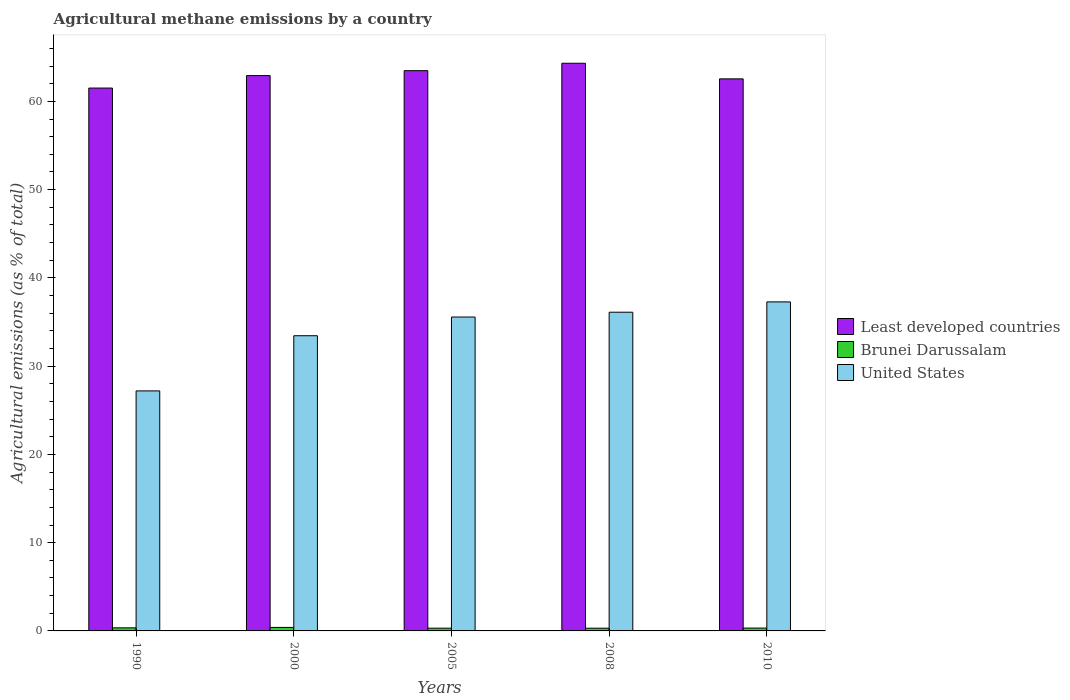How many different coloured bars are there?
Your answer should be compact. 3. Are the number of bars per tick equal to the number of legend labels?
Provide a short and direct response. Yes. How many bars are there on the 4th tick from the left?
Offer a terse response. 3. How many bars are there on the 1st tick from the right?
Offer a terse response. 3. What is the label of the 2nd group of bars from the left?
Give a very brief answer. 2000. What is the amount of agricultural methane emitted in Brunei Darussalam in 2005?
Your answer should be very brief. 0.31. Across all years, what is the maximum amount of agricultural methane emitted in Brunei Darussalam?
Provide a short and direct response. 0.4. Across all years, what is the minimum amount of agricultural methane emitted in Least developed countries?
Your answer should be very brief. 61.51. In which year was the amount of agricultural methane emitted in United States maximum?
Your answer should be very brief. 2010. In which year was the amount of agricultural methane emitted in Least developed countries minimum?
Your response must be concise. 1990. What is the total amount of agricultural methane emitted in Brunei Darussalam in the graph?
Offer a very short reply. 1.69. What is the difference between the amount of agricultural methane emitted in Brunei Darussalam in 2008 and that in 2010?
Give a very brief answer. -0.01. What is the difference between the amount of agricultural methane emitted in United States in 2000 and the amount of agricultural methane emitted in Brunei Darussalam in 2005?
Your answer should be compact. 33.13. What is the average amount of agricultural methane emitted in United States per year?
Keep it short and to the point. 33.92. In the year 1990, what is the difference between the amount of agricultural methane emitted in United States and amount of agricultural methane emitted in Brunei Darussalam?
Make the answer very short. 26.85. In how many years, is the amount of agricultural methane emitted in Brunei Darussalam greater than 16 %?
Provide a short and direct response. 0. What is the ratio of the amount of agricultural methane emitted in United States in 2005 to that in 2008?
Provide a succinct answer. 0.98. Is the amount of agricultural methane emitted in United States in 1990 less than that in 2005?
Make the answer very short. Yes. What is the difference between the highest and the second highest amount of agricultural methane emitted in Brunei Darussalam?
Ensure brevity in your answer.  0.05. What is the difference between the highest and the lowest amount of agricultural methane emitted in Brunei Darussalam?
Keep it short and to the point. 0.09. In how many years, is the amount of agricultural methane emitted in Least developed countries greater than the average amount of agricultural methane emitted in Least developed countries taken over all years?
Your response must be concise. 2. Is the sum of the amount of agricultural methane emitted in United States in 1990 and 2005 greater than the maximum amount of agricultural methane emitted in Brunei Darussalam across all years?
Keep it short and to the point. Yes. What does the 3rd bar from the left in 2010 represents?
Your answer should be compact. United States. What does the 3rd bar from the right in 1990 represents?
Keep it short and to the point. Least developed countries. Is it the case that in every year, the sum of the amount of agricultural methane emitted in Brunei Darussalam and amount of agricultural methane emitted in United States is greater than the amount of agricultural methane emitted in Least developed countries?
Provide a succinct answer. No. How many bars are there?
Your answer should be very brief. 15. What is the difference between two consecutive major ticks on the Y-axis?
Keep it short and to the point. 10. Does the graph contain any zero values?
Keep it short and to the point. No. Does the graph contain grids?
Offer a terse response. No. Where does the legend appear in the graph?
Offer a very short reply. Center right. How are the legend labels stacked?
Provide a short and direct response. Vertical. What is the title of the graph?
Provide a short and direct response. Agricultural methane emissions by a country. Does "Estonia" appear as one of the legend labels in the graph?
Give a very brief answer. No. What is the label or title of the X-axis?
Your answer should be compact. Years. What is the label or title of the Y-axis?
Make the answer very short. Agricultural emissions (as % of total). What is the Agricultural emissions (as % of total) of Least developed countries in 1990?
Give a very brief answer. 61.51. What is the Agricultural emissions (as % of total) in Brunei Darussalam in 1990?
Offer a very short reply. 0.35. What is the Agricultural emissions (as % of total) in United States in 1990?
Provide a succinct answer. 27.19. What is the Agricultural emissions (as % of total) in Least developed countries in 2000?
Your answer should be very brief. 62.92. What is the Agricultural emissions (as % of total) of Brunei Darussalam in 2000?
Provide a short and direct response. 0.4. What is the Agricultural emissions (as % of total) in United States in 2000?
Keep it short and to the point. 33.45. What is the Agricultural emissions (as % of total) in Least developed countries in 2005?
Provide a short and direct response. 63.48. What is the Agricultural emissions (as % of total) of Brunei Darussalam in 2005?
Offer a very short reply. 0.31. What is the Agricultural emissions (as % of total) in United States in 2005?
Your response must be concise. 35.56. What is the Agricultural emissions (as % of total) in Least developed countries in 2008?
Give a very brief answer. 64.32. What is the Agricultural emissions (as % of total) in Brunei Darussalam in 2008?
Offer a very short reply. 0.31. What is the Agricultural emissions (as % of total) in United States in 2008?
Make the answer very short. 36.11. What is the Agricultural emissions (as % of total) in Least developed countries in 2010?
Provide a succinct answer. 62.55. What is the Agricultural emissions (as % of total) in Brunei Darussalam in 2010?
Offer a terse response. 0.32. What is the Agricultural emissions (as % of total) of United States in 2010?
Make the answer very short. 37.28. Across all years, what is the maximum Agricultural emissions (as % of total) of Least developed countries?
Ensure brevity in your answer.  64.32. Across all years, what is the maximum Agricultural emissions (as % of total) in Brunei Darussalam?
Ensure brevity in your answer.  0.4. Across all years, what is the maximum Agricultural emissions (as % of total) in United States?
Provide a short and direct response. 37.28. Across all years, what is the minimum Agricultural emissions (as % of total) in Least developed countries?
Ensure brevity in your answer.  61.51. Across all years, what is the minimum Agricultural emissions (as % of total) in Brunei Darussalam?
Provide a succinct answer. 0.31. Across all years, what is the minimum Agricultural emissions (as % of total) in United States?
Offer a terse response. 27.19. What is the total Agricultural emissions (as % of total) in Least developed countries in the graph?
Your response must be concise. 314.77. What is the total Agricultural emissions (as % of total) of Brunei Darussalam in the graph?
Your answer should be compact. 1.69. What is the total Agricultural emissions (as % of total) in United States in the graph?
Give a very brief answer. 169.59. What is the difference between the Agricultural emissions (as % of total) in Least developed countries in 1990 and that in 2000?
Make the answer very short. -1.41. What is the difference between the Agricultural emissions (as % of total) of Brunei Darussalam in 1990 and that in 2000?
Ensure brevity in your answer.  -0.05. What is the difference between the Agricultural emissions (as % of total) of United States in 1990 and that in 2000?
Give a very brief answer. -6.25. What is the difference between the Agricultural emissions (as % of total) of Least developed countries in 1990 and that in 2005?
Ensure brevity in your answer.  -1.97. What is the difference between the Agricultural emissions (as % of total) of Brunei Darussalam in 1990 and that in 2005?
Offer a very short reply. 0.04. What is the difference between the Agricultural emissions (as % of total) in United States in 1990 and that in 2005?
Give a very brief answer. -8.37. What is the difference between the Agricultural emissions (as % of total) of Least developed countries in 1990 and that in 2008?
Provide a short and direct response. -2.81. What is the difference between the Agricultural emissions (as % of total) in Brunei Darussalam in 1990 and that in 2008?
Make the answer very short. 0.04. What is the difference between the Agricultural emissions (as % of total) of United States in 1990 and that in 2008?
Give a very brief answer. -8.92. What is the difference between the Agricultural emissions (as % of total) in Least developed countries in 1990 and that in 2010?
Your response must be concise. -1.04. What is the difference between the Agricultural emissions (as % of total) of Brunei Darussalam in 1990 and that in 2010?
Provide a succinct answer. 0.02. What is the difference between the Agricultural emissions (as % of total) of United States in 1990 and that in 2010?
Keep it short and to the point. -10.08. What is the difference between the Agricultural emissions (as % of total) in Least developed countries in 2000 and that in 2005?
Ensure brevity in your answer.  -0.56. What is the difference between the Agricultural emissions (as % of total) in Brunei Darussalam in 2000 and that in 2005?
Keep it short and to the point. 0.09. What is the difference between the Agricultural emissions (as % of total) in United States in 2000 and that in 2005?
Provide a short and direct response. -2.12. What is the difference between the Agricultural emissions (as % of total) of Least developed countries in 2000 and that in 2008?
Provide a short and direct response. -1.4. What is the difference between the Agricultural emissions (as % of total) in Brunei Darussalam in 2000 and that in 2008?
Make the answer very short. 0.09. What is the difference between the Agricultural emissions (as % of total) of United States in 2000 and that in 2008?
Give a very brief answer. -2.66. What is the difference between the Agricultural emissions (as % of total) in Least developed countries in 2000 and that in 2010?
Your response must be concise. 0.37. What is the difference between the Agricultural emissions (as % of total) of Brunei Darussalam in 2000 and that in 2010?
Make the answer very short. 0.07. What is the difference between the Agricultural emissions (as % of total) of United States in 2000 and that in 2010?
Provide a succinct answer. -3.83. What is the difference between the Agricultural emissions (as % of total) of Least developed countries in 2005 and that in 2008?
Your answer should be compact. -0.84. What is the difference between the Agricultural emissions (as % of total) in Brunei Darussalam in 2005 and that in 2008?
Your response must be concise. 0. What is the difference between the Agricultural emissions (as % of total) in United States in 2005 and that in 2008?
Your response must be concise. -0.54. What is the difference between the Agricultural emissions (as % of total) of Least developed countries in 2005 and that in 2010?
Offer a very short reply. 0.93. What is the difference between the Agricultural emissions (as % of total) in Brunei Darussalam in 2005 and that in 2010?
Your answer should be very brief. -0.01. What is the difference between the Agricultural emissions (as % of total) in United States in 2005 and that in 2010?
Offer a terse response. -1.71. What is the difference between the Agricultural emissions (as % of total) in Least developed countries in 2008 and that in 2010?
Make the answer very short. 1.77. What is the difference between the Agricultural emissions (as % of total) of Brunei Darussalam in 2008 and that in 2010?
Give a very brief answer. -0.01. What is the difference between the Agricultural emissions (as % of total) in United States in 2008 and that in 2010?
Provide a short and direct response. -1.17. What is the difference between the Agricultural emissions (as % of total) of Least developed countries in 1990 and the Agricultural emissions (as % of total) of Brunei Darussalam in 2000?
Offer a very short reply. 61.11. What is the difference between the Agricultural emissions (as % of total) in Least developed countries in 1990 and the Agricultural emissions (as % of total) in United States in 2000?
Offer a terse response. 28.06. What is the difference between the Agricultural emissions (as % of total) in Brunei Darussalam in 1990 and the Agricultural emissions (as % of total) in United States in 2000?
Ensure brevity in your answer.  -33.1. What is the difference between the Agricultural emissions (as % of total) of Least developed countries in 1990 and the Agricultural emissions (as % of total) of Brunei Darussalam in 2005?
Offer a very short reply. 61.2. What is the difference between the Agricultural emissions (as % of total) of Least developed countries in 1990 and the Agricultural emissions (as % of total) of United States in 2005?
Your answer should be very brief. 25.94. What is the difference between the Agricultural emissions (as % of total) in Brunei Darussalam in 1990 and the Agricultural emissions (as % of total) in United States in 2005?
Offer a terse response. -35.22. What is the difference between the Agricultural emissions (as % of total) in Least developed countries in 1990 and the Agricultural emissions (as % of total) in Brunei Darussalam in 2008?
Your answer should be compact. 61.2. What is the difference between the Agricultural emissions (as % of total) in Least developed countries in 1990 and the Agricultural emissions (as % of total) in United States in 2008?
Provide a short and direct response. 25.4. What is the difference between the Agricultural emissions (as % of total) of Brunei Darussalam in 1990 and the Agricultural emissions (as % of total) of United States in 2008?
Provide a short and direct response. -35.76. What is the difference between the Agricultural emissions (as % of total) in Least developed countries in 1990 and the Agricultural emissions (as % of total) in Brunei Darussalam in 2010?
Give a very brief answer. 61.18. What is the difference between the Agricultural emissions (as % of total) in Least developed countries in 1990 and the Agricultural emissions (as % of total) in United States in 2010?
Your answer should be compact. 24.23. What is the difference between the Agricultural emissions (as % of total) of Brunei Darussalam in 1990 and the Agricultural emissions (as % of total) of United States in 2010?
Provide a short and direct response. -36.93. What is the difference between the Agricultural emissions (as % of total) of Least developed countries in 2000 and the Agricultural emissions (as % of total) of Brunei Darussalam in 2005?
Your answer should be compact. 62.61. What is the difference between the Agricultural emissions (as % of total) of Least developed countries in 2000 and the Agricultural emissions (as % of total) of United States in 2005?
Your answer should be compact. 27.35. What is the difference between the Agricultural emissions (as % of total) in Brunei Darussalam in 2000 and the Agricultural emissions (as % of total) in United States in 2005?
Offer a terse response. -35.17. What is the difference between the Agricultural emissions (as % of total) in Least developed countries in 2000 and the Agricultural emissions (as % of total) in Brunei Darussalam in 2008?
Your response must be concise. 62.61. What is the difference between the Agricultural emissions (as % of total) in Least developed countries in 2000 and the Agricultural emissions (as % of total) in United States in 2008?
Your answer should be compact. 26.81. What is the difference between the Agricultural emissions (as % of total) in Brunei Darussalam in 2000 and the Agricultural emissions (as % of total) in United States in 2008?
Provide a short and direct response. -35.71. What is the difference between the Agricultural emissions (as % of total) in Least developed countries in 2000 and the Agricultural emissions (as % of total) in Brunei Darussalam in 2010?
Ensure brevity in your answer.  62.6. What is the difference between the Agricultural emissions (as % of total) of Least developed countries in 2000 and the Agricultural emissions (as % of total) of United States in 2010?
Provide a short and direct response. 25.64. What is the difference between the Agricultural emissions (as % of total) in Brunei Darussalam in 2000 and the Agricultural emissions (as % of total) in United States in 2010?
Make the answer very short. -36.88. What is the difference between the Agricultural emissions (as % of total) of Least developed countries in 2005 and the Agricultural emissions (as % of total) of Brunei Darussalam in 2008?
Provide a short and direct response. 63.17. What is the difference between the Agricultural emissions (as % of total) of Least developed countries in 2005 and the Agricultural emissions (as % of total) of United States in 2008?
Ensure brevity in your answer.  27.37. What is the difference between the Agricultural emissions (as % of total) in Brunei Darussalam in 2005 and the Agricultural emissions (as % of total) in United States in 2008?
Provide a succinct answer. -35.8. What is the difference between the Agricultural emissions (as % of total) in Least developed countries in 2005 and the Agricultural emissions (as % of total) in Brunei Darussalam in 2010?
Ensure brevity in your answer.  63.15. What is the difference between the Agricultural emissions (as % of total) of Least developed countries in 2005 and the Agricultural emissions (as % of total) of United States in 2010?
Your answer should be compact. 26.2. What is the difference between the Agricultural emissions (as % of total) of Brunei Darussalam in 2005 and the Agricultural emissions (as % of total) of United States in 2010?
Provide a succinct answer. -36.97. What is the difference between the Agricultural emissions (as % of total) in Least developed countries in 2008 and the Agricultural emissions (as % of total) in Brunei Darussalam in 2010?
Your answer should be compact. 63.99. What is the difference between the Agricultural emissions (as % of total) in Least developed countries in 2008 and the Agricultural emissions (as % of total) in United States in 2010?
Make the answer very short. 27.04. What is the difference between the Agricultural emissions (as % of total) of Brunei Darussalam in 2008 and the Agricultural emissions (as % of total) of United States in 2010?
Provide a short and direct response. -36.97. What is the average Agricultural emissions (as % of total) in Least developed countries per year?
Offer a terse response. 62.95. What is the average Agricultural emissions (as % of total) of Brunei Darussalam per year?
Your answer should be very brief. 0.34. What is the average Agricultural emissions (as % of total) of United States per year?
Your response must be concise. 33.92. In the year 1990, what is the difference between the Agricultural emissions (as % of total) of Least developed countries and Agricultural emissions (as % of total) of Brunei Darussalam?
Ensure brevity in your answer.  61.16. In the year 1990, what is the difference between the Agricultural emissions (as % of total) of Least developed countries and Agricultural emissions (as % of total) of United States?
Provide a succinct answer. 34.31. In the year 1990, what is the difference between the Agricultural emissions (as % of total) of Brunei Darussalam and Agricultural emissions (as % of total) of United States?
Your answer should be very brief. -26.85. In the year 2000, what is the difference between the Agricultural emissions (as % of total) of Least developed countries and Agricultural emissions (as % of total) of Brunei Darussalam?
Keep it short and to the point. 62.52. In the year 2000, what is the difference between the Agricultural emissions (as % of total) of Least developed countries and Agricultural emissions (as % of total) of United States?
Your answer should be very brief. 29.47. In the year 2000, what is the difference between the Agricultural emissions (as % of total) in Brunei Darussalam and Agricultural emissions (as % of total) in United States?
Keep it short and to the point. -33.05. In the year 2005, what is the difference between the Agricultural emissions (as % of total) in Least developed countries and Agricultural emissions (as % of total) in Brunei Darussalam?
Your answer should be compact. 63.17. In the year 2005, what is the difference between the Agricultural emissions (as % of total) of Least developed countries and Agricultural emissions (as % of total) of United States?
Ensure brevity in your answer.  27.91. In the year 2005, what is the difference between the Agricultural emissions (as % of total) in Brunei Darussalam and Agricultural emissions (as % of total) in United States?
Keep it short and to the point. -35.25. In the year 2008, what is the difference between the Agricultural emissions (as % of total) in Least developed countries and Agricultural emissions (as % of total) in Brunei Darussalam?
Offer a very short reply. 64.01. In the year 2008, what is the difference between the Agricultural emissions (as % of total) of Least developed countries and Agricultural emissions (as % of total) of United States?
Ensure brevity in your answer.  28.21. In the year 2008, what is the difference between the Agricultural emissions (as % of total) in Brunei Darussalam and Agricultural emissions (as % of total) in United States?
Provide a succinct answer. -35.8. In the year 2010, what is the difference between the Agricultural emissions (as % of total) in Least developed countries and Agricultural emissions (as % of total) in Brunei Darussalam?
Ensure brevity in your answer.  62.23. In the year 2010, what is the difference between the Agricultural emissions (as % of total) in Least developed countries and Agricultural emissions (as % of total) in United States?
Offer a terse response. 25.27. In the year 2010, what is the difference between the Agricultural emissions (as % of total) in Brunei Darussalam and Agricultural emissions (as % of total) in United States?
Make the answer very short. -36.96. What is the ratio of the Agricultural emissions (as % of total) of Least developed countries in 1990 to that in 2000?
Provide a short and direct response. 0.98. What is the ratio of the Agricultural emissions (as % of total) in Brunei Darussalam in 1990 to that in 2000?
Your answer should be compact. 0.88. What is the ratio of the Agricultural emissions (as % of total) of United States in 1990 to that in 2000?
Offer a very short reply. 0.81. What is the ratio of the Agricultural emissions (as % of total) in Least developed countries in 1990 to that in 2005?
Your response must be concise. 0.97. What is the ratio of the Agricultural emissions (as % of total) in Brunei Darussalam in 1990 to that in 2005?
Provide a succinct answer. 1.12. What is the ratio of the Agricultural emissions (as % of total) of United States in 1990 to that in 2005?
Keep it short and to the point. 0.76. What is the ratio of the Agricultural emissions (as % of total) of Least developed countries in 1990 to that in 2008?
Keep it short and to the point. 0.96. What is the ratio of the Agricultural emissions (as % of total) in Brunei Darussalam in 1990 to that in 2008?
Your response must be concise. 1.12. What is the ratio of the Agricultural emissions (as % of total) in United States in 1990 to that in 2008?
Your response must be concise. 0.75. What is the ratio of the Agricultural emissions (as % of total) of Least developed countries in 1990 to that in 2010?
Your answer should be very brief. 0.98. What is the ratio of the Agricultural emissions (as % of total) of Brunei Darussalam in 1990 to that in 2010?
Your answer should be compact. 1.08. What is the ratio of the Agricultural emissions (as % of total) of United States in 1990 to that in 2010?
Ensure brevity in your answer.  0.73. What is the ratio of the Agricultural emissions (as % of total) in Least developed countries in 2000 to that in 2005?
Your answer should be very brief. 0.99. What is the ratio of the Agricultural emissions (as % of total) of Brunei Darussalam in 2000 to that in 2005?
Offer a terse response. 1.28. What is the ratio of the Agricultural emissions (as % of total) of United States in 2000 to that in 2005?
Keep it short and to the point. 0.94. What is the ratio of the Agricultural emissions (as % of total) of Least developed countries in 2000 to that in 2008?
Ensure brevity in your answer.  0.98. What is the ratio of the Agricultural emissions (as % of total) in Brunei Darussalam in 2000 to that in 2008?
Your response must be concise. 1.28. What is the ratio of the Agricultural emissions (as % of total) of United States in 2000 to that in 2008?
Keep it short and to the point. 0.93. What is the ratio of the Agricultural emissions (as % of total) of Least developed countries in 2000 to that in 2010?
Offer a very short reply. 1.01. What is the ratio of the Agricultural emissions (as % of total) of Brunei Darussalam in 2000 to that in 2010?
Offer a very short reply. 1.23. What is the ratio of the Agricultural emissions (as % of total) of United States in 2000 to that in 2010?
Keep it short and to the point. 0.9. What is the ratio of the Agricultural emissions (as % of total) of Least developed countries in 2005 to that in 2008?
Your answer should be compact. 0.99. What is the ratio of the Agricultural emissions (as % of total) in United States in 2005 to that in 2008?
Give a very brief answer. 0.98. What is the ratio of the Agricultural emissions (as % of total) of Least developed countries in 2005 to that in 2010?
Make the answer very short. 1.01. What is the ratio of the Agricultural emissions (as % of total) in Brunei Darussalam in 2005 to that in 2010?
Provide a short and direct response. 0.96. What is the ratio of the Agricultural emissions (as % of total) of United States in 2005 to that in 2010?
Give a very brief answer. 0.95. What is the ratio of the Agricultural emissions (as % of total) of Least developed countries in 2008 to that in 2010?
Give a very brief answer. 1.03. What is the ratio of the Agricultural emissions (as % of total) of Brunei Darussalam in 2008 to that in 2010?
Your response must be concise. 0.96. What is the ratio of the Agricultural emissions (as % of total) of United States in 2008 to that in 2010?
Offer a very short reply. 0.97. What is the difference between the highest and the second highest Agricultural emissions (as % of total) of Least developed countries?
Offer a terse response. 0.84. What is the difference between the highest and the second highest Agricultural emissions (as % of total) of Brunei Darussalam?
Your answer should be very brief. 0.05. What is the difference between the highest and the second highest Agricultural emissions (as % of total) in United States?
Provide a succinct answer. 1.17. What is the difference between the highest and the lowest Agricultural emissions (as % of total) in Least developed countries?
Ensure brevity in your answer.  2.81. What is the difference between the highest and the lowest Agricultural emissions (as % of total) in Brunei Darussalam?
Offer a terse response. 0.09. What is the difference between the highest and the lowest Agricultural emissions (as % of total) of United States?
Your response must be concise. 10.08. 